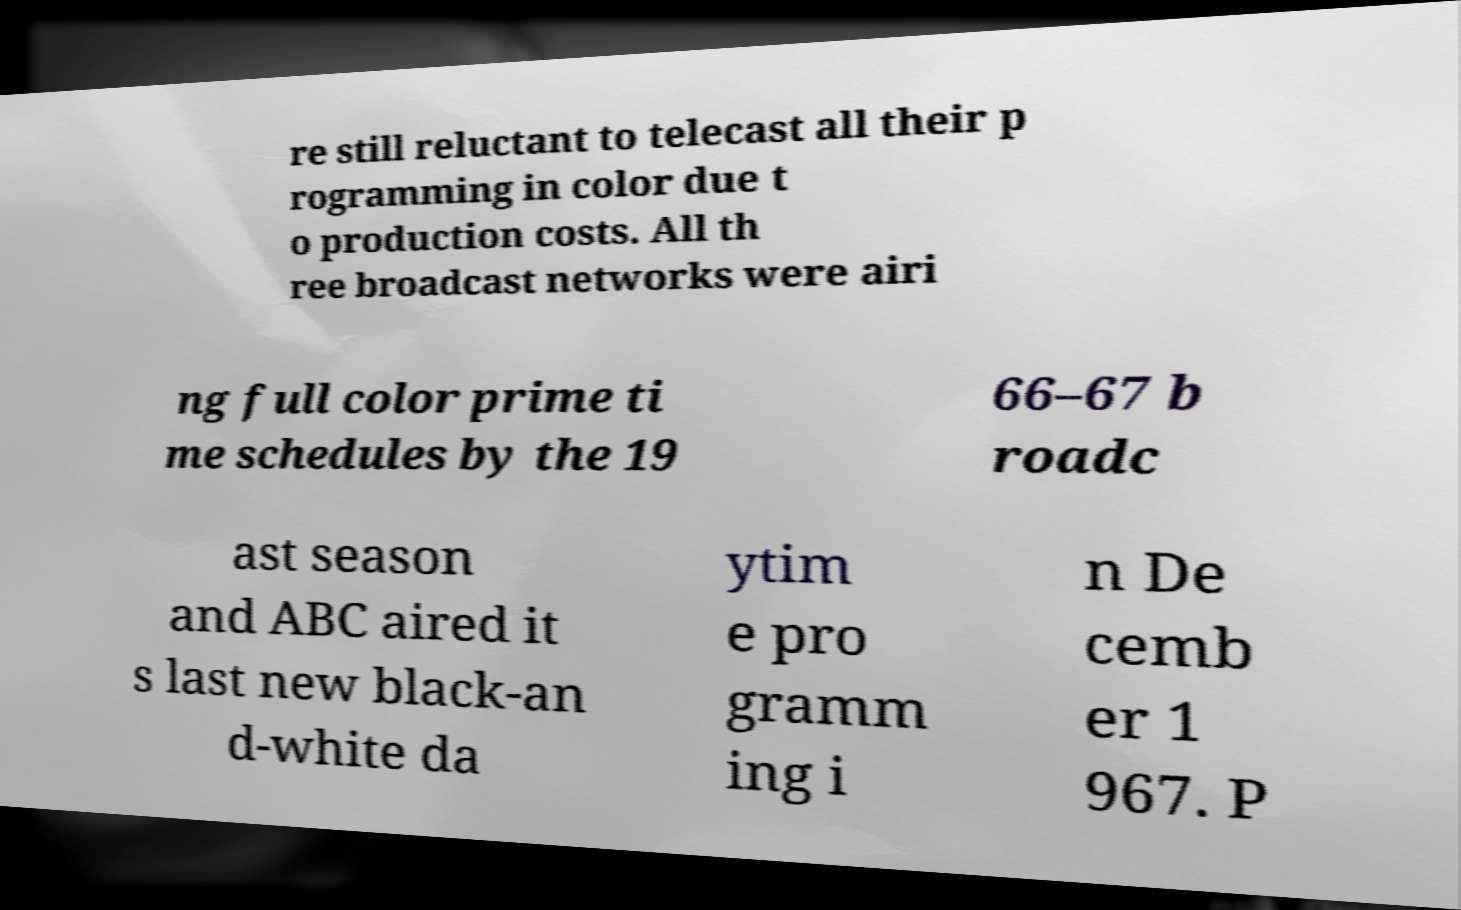Could you extract and type out the text from this image? re still reluctant to telecast all their p rogramming in color due t o production costs. All th ree broadcast networks were airi ng full color prime ti me schedules by the 19 66–67 b roadc ast season and ABC aired it s last new black-an d-white da ytim e pro gramm ing i n De cemb er 1 967. P 